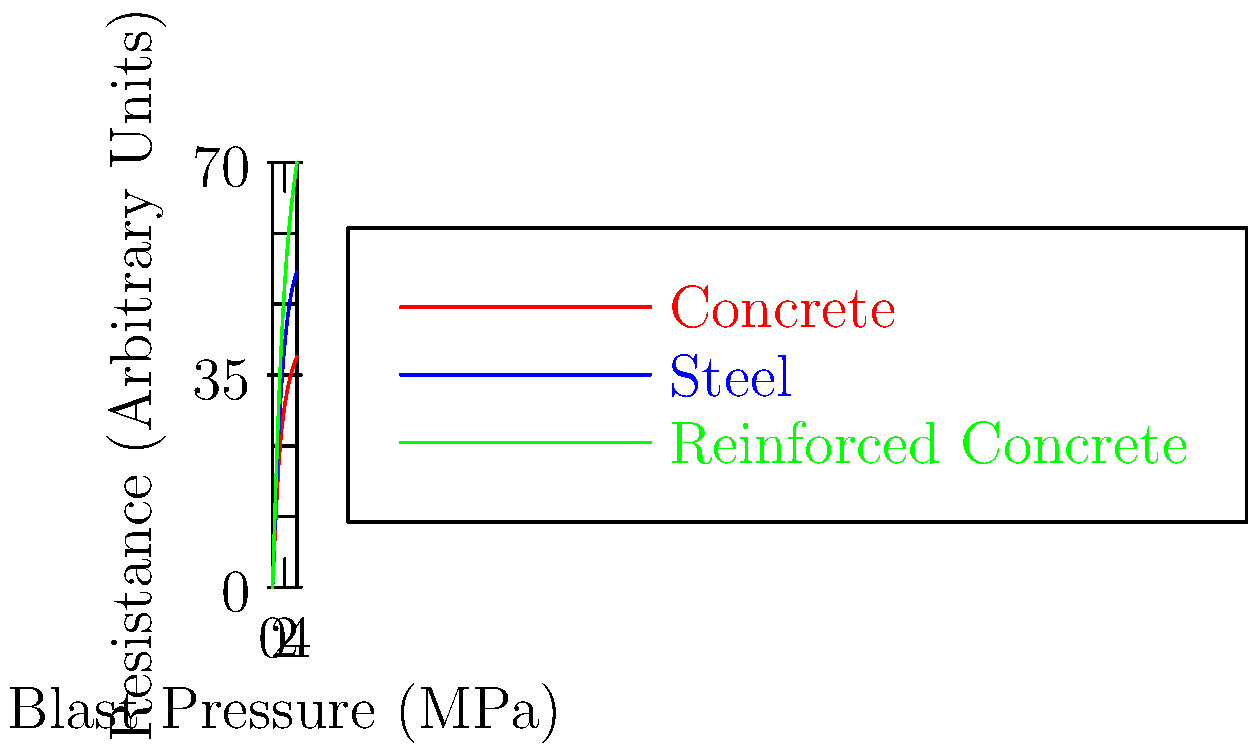Based on the cross-sectional diagram comparing blast resistance of various building materials, which material shows the highest resistance to increasing blast pressure, and how might this inform procurement decisions for military infrastructure in high-risk areas? To answer this question, let's analyze the graph step-by-step:

1. The graph shows three materials: Concrete (red), Steel (blue), and Reinforced Concrete (green).

2. The x-axis represents Blast Pressure in MPa, while the y-axis shows Resistance in arbitrary units.

3. As we move from left to right (increasing blast pressure):
   a. Concrete (red) shows the lowest curve, indicating the least resistance.
   b. Steel (blue) shows a higher curve than concrete, indicating better resistance.
   c. Reinforced Concrete (green) shows the highest curve, indicating the best resistance.

4. At the maximum blast pressure shown (4 MPa):
   a. Concrete reaches about 38 units of resistance.
   b. Steel reaches about 52 units of resistance.
   c. Reinforced Concrete reaches about 70 units of resistance.

5. Reinforced Concrete consistently shows the highest resistance across all pressure levels.

6. For procurement decisions in high-risk areas:
   a. Reinforced Concrete would be the best choice for blast-resistant structures.
   b. It combines the compressive strength of concrete with the tensile strength of steel.
   c. This material would provide the best protection for military personnel and equipment.
   d. While potentially more expensive, the increased safety justifies the cost in high-risk areas.

7. However, other factors such as cost, availability, and ease of construction should also be considered in the final procurement decision.
Answer: Reinforced Concrete; it offers the highest blast resistance, making it the optimal choice for military infrastructure in high-risk areas, balancing protection and cost-effectiveness. 